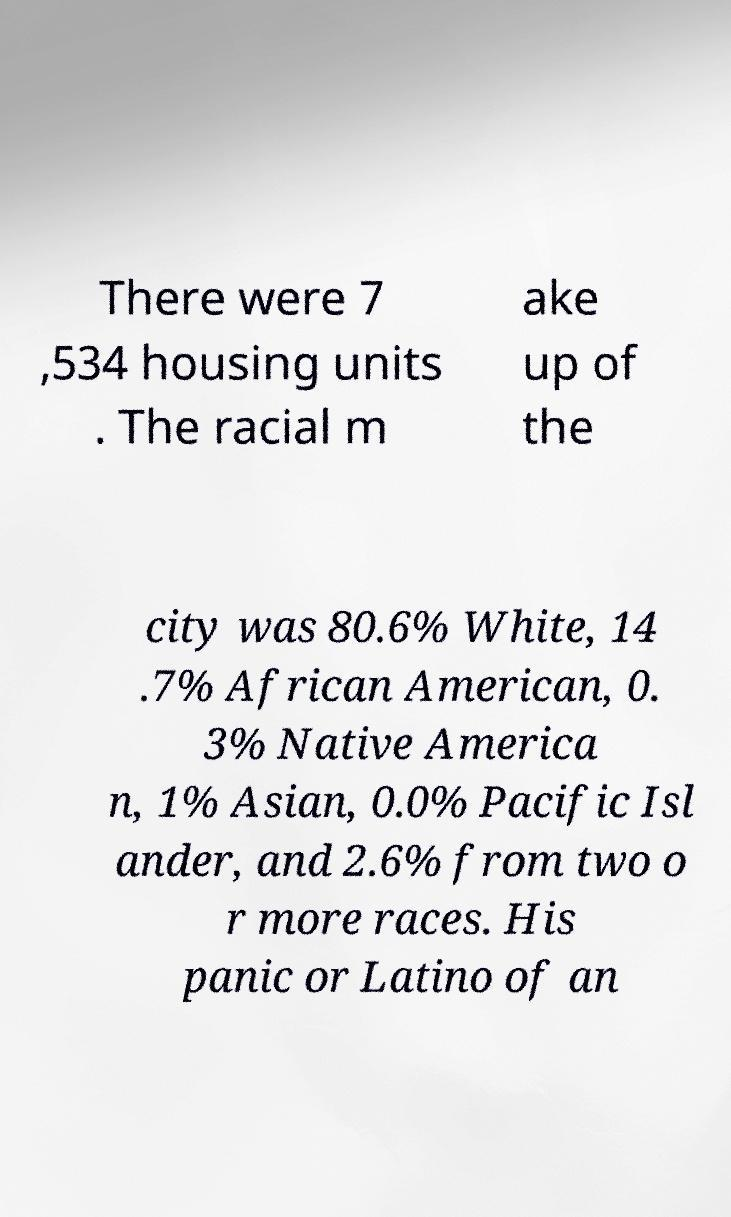For documentation purposes, I need the text within this image transcribed. Could you provide that? There were 7 ,534 housing units . The racial m ake up of the city was 80.6% White, 14 .7% African American, 0. 3% Native America n, 1% Asian, 0.0% Pacific Isl ander, and 2.6% from two o r more races. His panic or Latino of an 